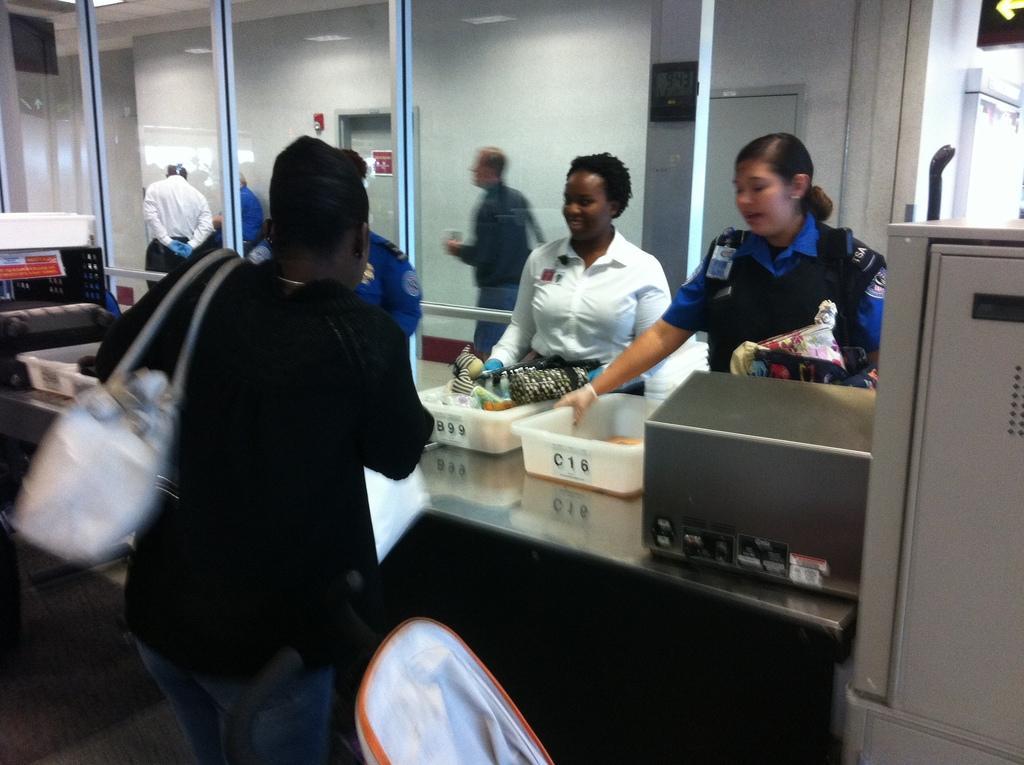In one or two sentences, can you explain what this image depicts? In the picture I can see a woman standing on the floor and she is carrying a bag. I can see the plastic boxes on the metal table. I can see a woman on the right side and looks like she is wearing a safety jacket. In the background, I can see the glass window and there are three persons walking on the floor. 